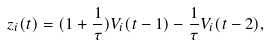<formula> <loc_0><loc_0><loc_500><loc_500>z _ { i } ( t ) = ( 1 + \frac { 1 } { \tau } ) V _ { i } ( t - 1 ) - \frac { 1 } { \tau } V _ { i } ( t - 2 ) ,</formula> 